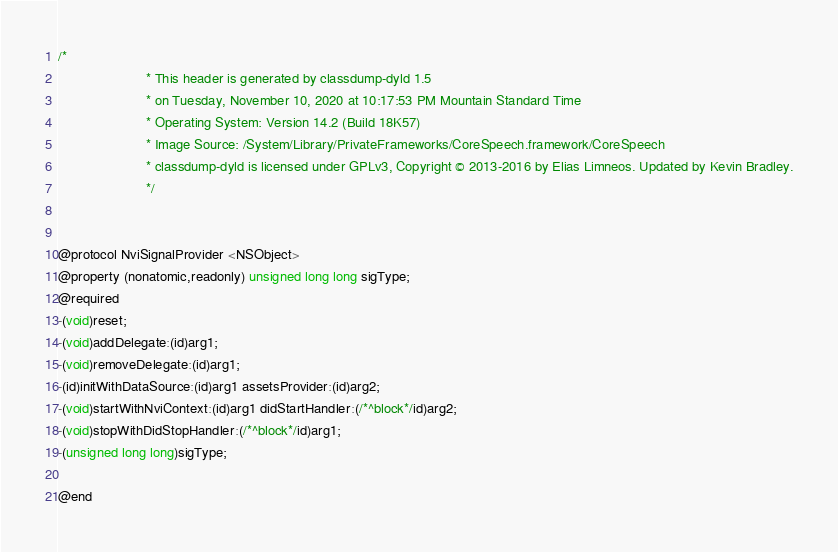<code> <loc_0><loc_0><loc_500><loc_500><_C_>/*
                       * This header is generated by classdump-dyld 1.5
                       * on Tuesday, November 10, 2020 at 10:17:53 PM Mountain Standard Time
                       * Operating System: Version 14.2 (Build 18K57)
                       * Image Source: /System/Library/PrivateFrameworks/CoreSpeech.framework/CoreSpeech
                       * classdump-dyld is licensed under GPLv3, Copyright © 2013-2016 by Elias Limneos. Updated by Kevin Bradley.
                       */


@protocol NviSignalProvider <NSObject>
@property (nonatomic,readonly) unsigned long long sigType; 
@required
-(void)reset;
-(void)addDelegate:(id)arg1;
-(void)removeDelegate:(id)arg1;
-(id)initWithDataSource:(id)arg1 assetsProvider:(id)arg2;
-(void)startWithNviContext:(id)arg1 didStartHandler:(/*^block*/id)arg2;
-(void)stopWithDidStopHandler:(/*^block*/id)arg1;
-(unsigned long long)sigType;

@end

</code> 